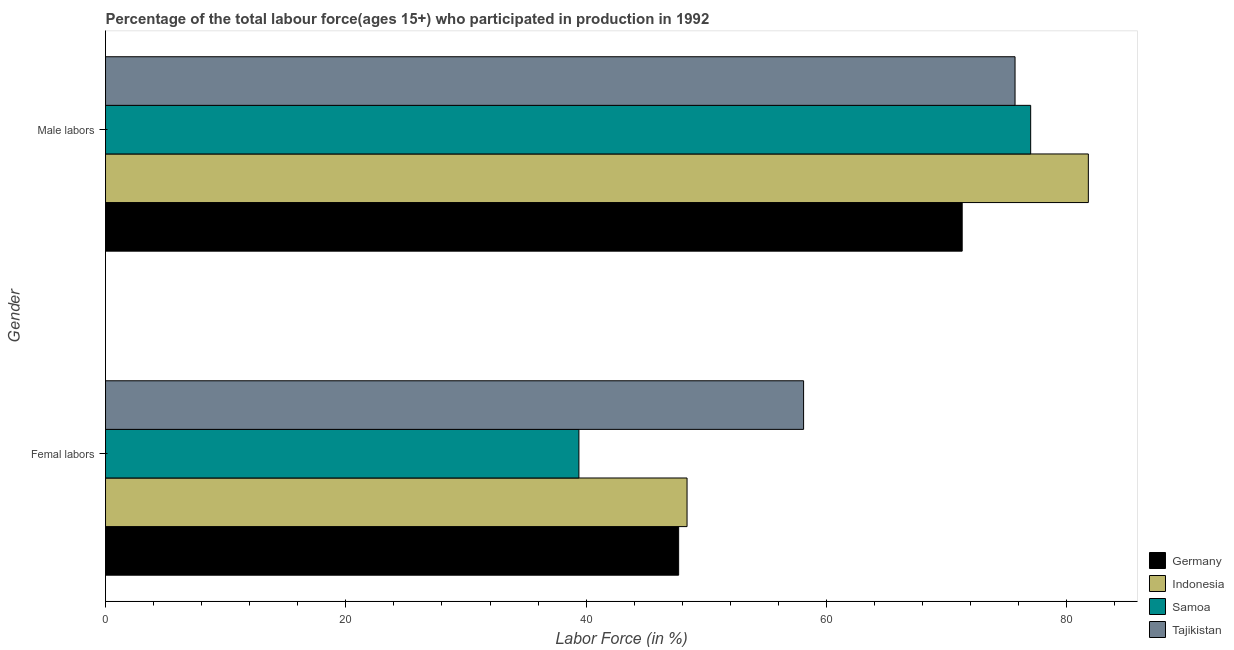How many different coloured bars are there?
Your answer should be very brief. 4. How many groups of bars are there?
Make the answer very short. 2. Are the number of bars on each tick of the Y-axis equal?
Provide a short and direct response. Yes. How many bars are there on the 2nd tick from the bottom?
Offer a very short reply. 4. What is the label of the 2nd group of bars from the top?
Give a very brief answer. Femal labors. What is the percentage of female labor force in Indonesia?
Ensure brevity in your answer.  48.4. Across all countries, what is the maximum percentage of male labour force?
Keep it short and to the point. 81.8. Across all countries, what is the minimum percentage of female labor force?
Your response must be concise. 39.4. In which country was the percentage of male labour force maximum?
Keep it short and to the point. Indonesia. In which country was the percentage of male labour force minimum?
Provide a succinct answer. Germany. What is the total percentage of female labor force in the graph?
Give a very brief answer. 193.6. What is the difference between the percentage of male labour force in Samoa and that in Germany?
Offer a very short reply. 5.7. What is the difference between the percentage of female labor force in Indonesia and the percentage of male labour force in Germany?
Ensure brevity in your answer.  -22.9. What is the average percentage of female labor force per country?
Give a very brief answer. 48.4. What is the difference between the percentage of female labor force and percentage of male labour force in Indonesia?
Offer a very short reply. -33.4. In how many countries, is the percentage of female labor force greater than 8 %?
Provide a succinct answer. 4. What is the ratio of the percentage of male labour force in Indonesia to that in Tajikistan?
Ensure brevity in your answer.  1.08. In how many countries, is the percentage of female labor force greater than the average percentage of female labor force taken over all countries?
Give a very brief answer. 2. How many bars are there?
Your answer should be very brief. 8. What is the difference between two consecutive major ticks on the X-axis?
Provide a short and direct response. 20. Are the values on the major ticks of X-axis written in scientific E-notation?
Make the answer very short. No. Does the graph contain any zero values?
Offer a very short reply. No. What is the title of the graph?
Provide a short and direct response. Percentage of the total labour force(ages 15+) who participated in production in 1992. What is the label or title of the X-axis?
Ensure brevity in your answer.  Labor Force (in %). What is the Labor Force (in %) of Germany in Femal labors?
Keep it short and to the point. 47.7. What is the Labor Force (in %) in Indonesia in Femal labors?
Provide a succinct answer. 48.4. What is the Labor Force (in %) of Samoa in Femal labors?
Your answer should be compact. 39.4. What is the Labor Force (in %) in Tajikistan in Femal labors?
Your answer should be very brief. 58.1. What is the Labor Force (in %) of Germany in Male labors?
Offer a terse response. 71.3. What is the Labor Force (in %) of Indonesia in Male labors?
Your answer should be very brief. 81.8. What is the Labor Force (in %) in Tajikistan in Male labors?
Provide a short and direct response. 75.7. Across all Gender, what is the maximum Labor Force (in %) in Germany?
Offer a very short reply. 71.3. Across all Gender, what is the maximum Labor Force (in %) in Indonesia?
Offer a terse response. 81.8. Across all Gender, what is the maximum Labor Force (in %) in Samoa?
Offer a very short reply. 77. Across all Gender, what is the maximum Labor Force (in %) of Tajikistan?
Ensure brevity in your answer.  75.7. Across all Gender, what is the minimum Labor Force (in %) in Germany?
Offer a very short reply. 47.7. Across all Gender, what is the minimum Labor Force (in %) of Indonesia?
Provide a succinct answer. 48.4. Across all Gender, what is the minimum Labor Force (in %) in Samoa?
Provide a succinct answer. 39.4. Across all Gender, what is the minimum Labor Force (in %) in Tajikistan?
Provide a succinct answer. 58.1. What is the total Labor Force (in %) in Germany in the graph?
Provide a short and direct response. 119. What is the total Labor Force (in %) in Indonesia in the graph?
Provide a short and direct response. 130.2. What is the total Labor Force (in %) of Samoa in the graph?
Offer a very short reply. 116.4. What is the total Labor Force (in %) of Tajikistan in the graph?
Provide a short and direct response. 133.8. What is the difference between the Labor Force (in %) of Germany in Femal labors and that in Male labors?
Keep it short and to the point. -23.6. What is the difference between the Labor Force (in %) of Indonesia in Femal labors and that in Male labors?
Your response must be concise. -33.4. What is the difference between the Labor Force (in %) in Samoa in Femal labors and that in Male labors?
Your response must be concise. -37.6. What is the difference between the Labor Force (in %) in Tajikistan in Femal labors and that in Male labors?
Your response must be concise. -17.6. What is the difference between the Labor Force (in %) in Germany in Femal labors and the Labor Force (in %) in Indonesia in Male labors?
Offer a very short reply. -34.1. What is the difference between the Labor Force (in %) of Germany in Femal labors and the Labor Force (in %) of Samoa in Male labors?
Give a very brief answer. -29.3. What is the difference between the Labor Force (in %) in Indonesia in Femal labors and the Labor Force (in %) in Samoa in Male labors?
Offer a very short reply. -28.6. What is the difference between the Labor Force (in %) in Indonesia in Femal labors and the Labor Force (in %) in Tajikistan in Male labors?
Keep it short and to the point. -27.3. What is the difference between the Labor Force (in %) of Samoa in Femal labors and the Labor Force (in %) of Tajikistan in Male labors?
Make the answer very short. -36.3. What is the average Labor Force (in %) of Germany per Gender?
Your response must be concise. 59.5. What is the average Labor Force (in %) in Indonesia per Gender?
Provide a succinct answer. 65.1. What is the average Labor Force (in %) of Samoa per Gender?
Provide a short and direct response. 58.2. What is the average Labor Force (in %) in Tajikistan per Gender?
Ensure brevity in your answer.  66.9. What is the difference between the Labor Force (in %) of Germany and Labor Force (in %) of Indonesia in Femal labors?
Your answer should be very brief. -0.7. What is the difference between the Labor Force (in %) in Germany and Labor Force (in %) in Samoa in Femal labors?
Your response must be concise. 8.3. What is the difference between the Labor Force (in %) in Samoa and Labor Force (in %) in Tajikistan in Femal labors?
Your answer should be compact. -18.7. What is the difference between the Labor Force (in %) of Germany and Labor Force (in %) of Indonesia in Male labors?
Offer a very short reply. -10.5. What is the difference between the Labor Force (in %) of Germany and Labor Force (in %) of Samoa in Male labors?
Provide a short and direct response. -5.7. What is the difference between the Labor Force (in %) in Germany and Labor Force (in %) in Tajikistan in Male labors?
Provide a succinct answer. -4.4. What is the difference between the Labor Force (in %) in Samoa and Labor Force (in %) in Tajikistan in Male labors?
Give a very brief answer. 1.3. What is the ratio of the Labor Force (in %) in Germany in Femal labors to that in Male labors?
Offer a very short reply. 0.67. What is the ratio of the Labor Force (in %) of Indonesia in Femal labors to that in Male labors?
Offer a terse response. 0.59. What is the ratio of the Labor Force (in %) of Samoa in Femal labors to that in Male labors?
Your answer should be very brief. 0.51. What is the ratio of the Labor Force (in %) of Tajikistan in Femal labors to that in Male labors?
Make the answer very short. 0.77. What is the difference between the highest and the second highest Labor Force (in %) of Germany?
Keep it short and to the point. 23.6. What is the difference between the highest and the second highest Labor Force (in %) in Indonesia?
Your answer should be compact. 33.4. What is the difference between the highest and the second highest Labor Force (in %) in Samoa?
Provide a succinct answer. 37.6. What is the difference between the highest and the second highest Labor Force (in %) in Tajikistan?
Your answer should be very brief. 17.6. What is the difference between the highest and the lowest Labor Force (in %) of Germany?
Offer a very short reply. 23.6. What is the difference between the highest and the lowest Labor Force (in %) of Indonesia?
Your response must be concise. 33.4. What is the difference between the highest and the lowest Labor Force (in %) in Samoa?
Provide a succinct answer. 37.6. 